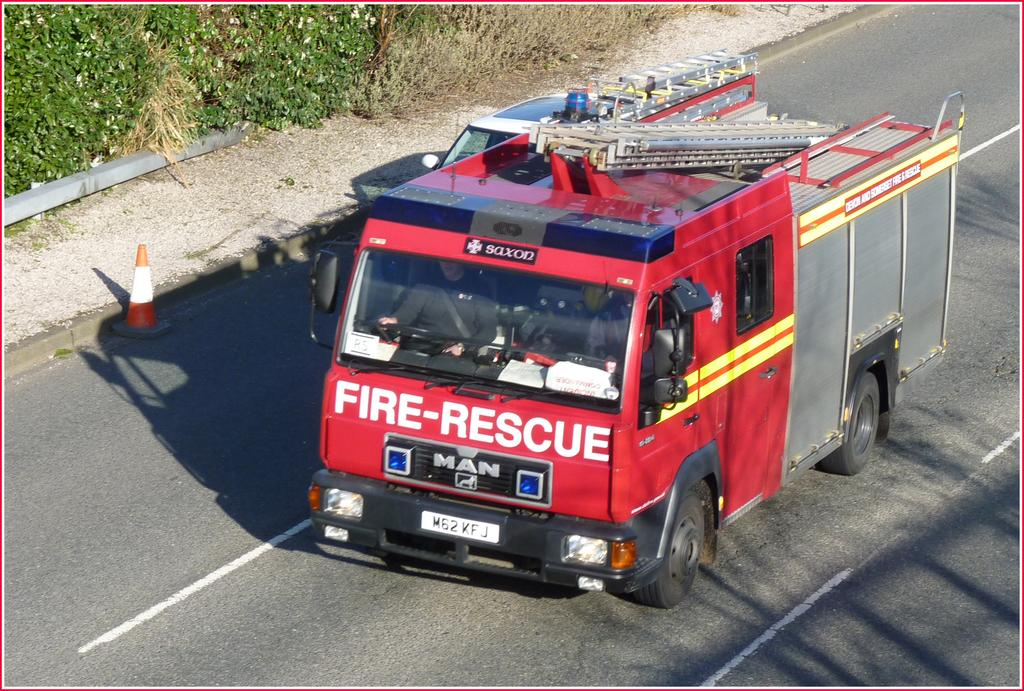What type of vehicle is in the image? There is a car in the image. Where is the car located in the image? The car is on the road in the image. What else can be seen on the road in the image? The vehicle and car are both on the road. What is visible at the top of the image? Plants are visible at the top of the image. What type of fang can be seen in the image? There is no fang present in the image. Can you tell me which secretary is driving the car in the image? There is no mention of a secretary or any person driving the car in the image. 